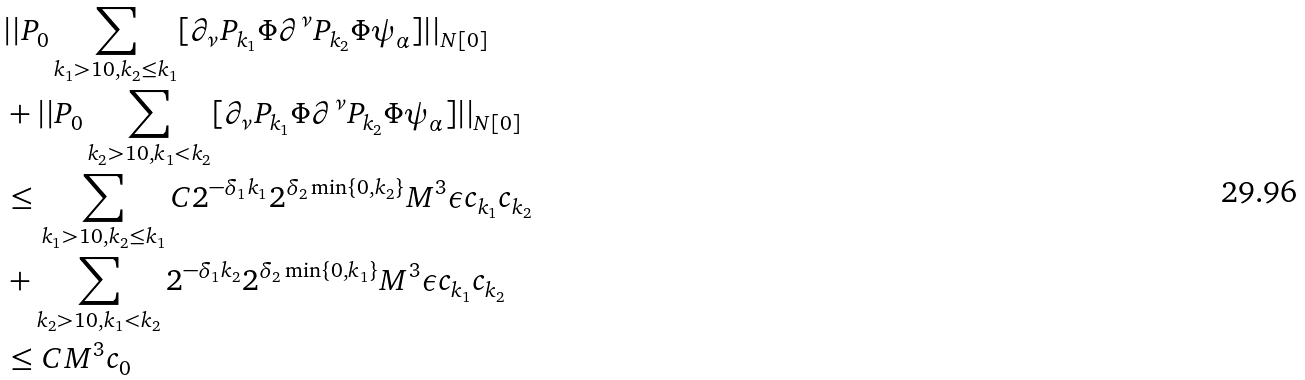<formula> <loc_0><loc_0><loc_500><loc_500>& | | P _ { 0 } \sum _ { k _ { 1 } > 1 0 , k _ { 2 } \leq k _ { 1 } } [ \partial _ { \nu } P _ { k _ { 1 } } \Phi \partial ^ { \nu } P _ { k _ { 2 } } \Phi \psi _ { \alpha } ] | | _ { N [ 0 ] } \\ & + | | P _ { 0 } \sum _ { k _ { 2 } > 1 0 , k _ { 1 } < k _ { 2 } } [ \partial _ { \nu } P _ { k _ { 1 } } \Phi \partial ^ { \nu } P _ { k _ { 2 } } \Phi \psi _ { \alpha } ] | | _ { N [ 0 ] } \\ & \leq \sum _ { k _ { 1 } > 1 0 , k _ { 2 } \leq k _ { 1 } } C 2 ^ { - \delta _ { 1 } k _ { 1 } } 2 ^ { \delta _ { 2 } \min \{ 0 , k _ { 2 } \} } M ^ { 3 } \epsilon c _ { k _ { 1 } } c _ { k _ { 2 } } \\ & + \sum _ { k _ { 2 } > 1 0 , k _ { 1 } < k _ { 2 } } 2 ^ { - \delta _ { 1 } k _ { 2 } } 2 ^ { \delta _ { 2 } \min \{ 0 , k _ { 1 } \} } M ^ { 3 } \epsilon c _ { k _ { 1 } } c _ { k _ { 2 } } \\ & \leq C M ^ { 3 } c _ { 0 } \\</formula> 